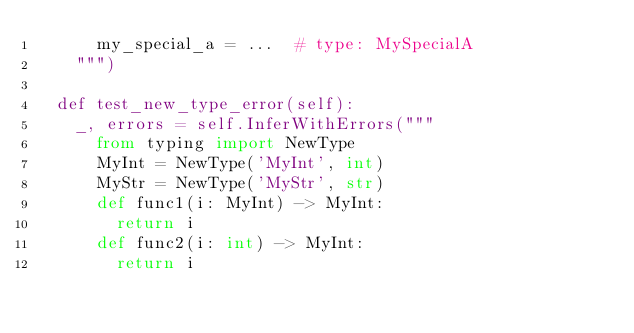Convert code to text. <code><loc_0><loc_0><loc_500><loc_500><_Python_>      my_special_a = ...  # type: MySpecialA
    """)

  def test_new_type_error(self):
    _, errors = self.InferWithErrors("""
      from typing import NewType
      MyInt = NewType('MyInt', int)
      MyStr = NewType('MyStr', str)
      def func1(i: MyInt) -> MyInt:
        return i
      def func2(i: int) -> MyInt:
        return i</code> 